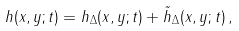Convert formula to latex. <formula><loc_0><loc_0><loc_500><loc_500>h ( x , y ; t ) = h _ { \Delta } ( x , y ; t ) + \tilde { h } _ { \Delta } ( x , y ; t ) \, ,</formula> 